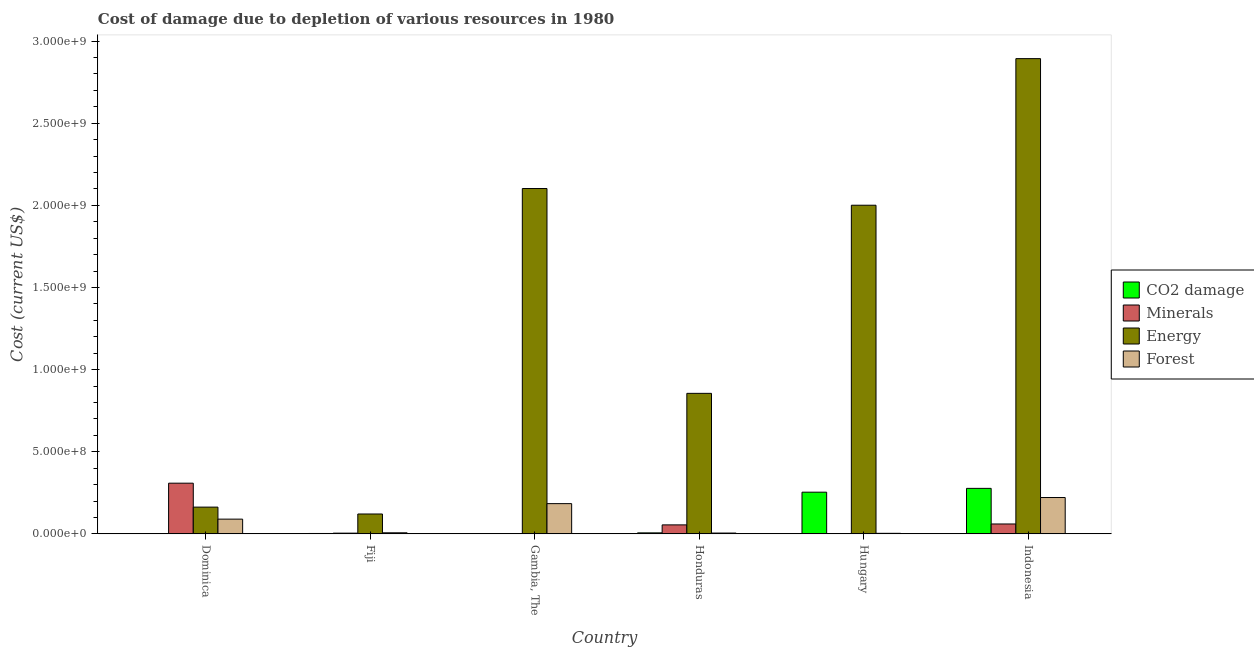How many bars are there on the 4th tick from the right?
Keep it short and to the point. 4. What is the label of the 2nd group of bars from the left?
Your answer should be compact. Fiji. What is the cost of damage due to depletion of coal in Honduras?
Provide a succinct answer. 6.01e+06. Across all countries, what is the maximum cost of damage due to depletion of minerals?
Give a very brief answer. 3.09e+08. Across all countries, what is the minimum cost of damage due to depletion of energy?
Provide a short and direct response. 1.21e+08. In which country was the cost of damage due to depletion of minerals maximum?
Provide a succinct answer. Dominica. In which country was the cost of damage due to depletion of energy minimum?
Provide a short and direct response. Fiji. What is the total cost of damage due to depletion of energy in the graph?
Provide a short and direct response. 8.14e+09. What is the difference between the cost of damage due to depletion of coal in Dominica and that in Honduras?
Your answer should be very brief. -5.90e+06. What is the difference between the cost of damage due to depletion of energy in Fiji and the cost of damage due to depletion of minerals in Indonesia?
Give a very brief answer. 6.08e+07. What is the average cost of damage due to depletion of forests per country?
Provide a short and direct response. 8.49e+07. What is the difference between the cost of damage due to depletion of energy and cost of damage due to depletion of minerals in Hungary?
Provide a short and direct response. 2.00e+09. In how many countries, is the cost of damage due to depletion of forests greater than 1900000000 US$?
Make the answer very short. 0. What is the ratio of the cost of damage due to depletion of coal in Fiji to that in Indonesia?
Ensure brevity in your answer.  0.01. Is the cost of damage due to depletion of energy in Dominica less than that in Fiji?
Make the answer very short. No. What is the difference between the highest and the second highest cost of damage due to depletion of minerals?
Make the answer very short. 2.48e+08. What is the difference between the highest and the lowest cost of damage due to depletion of minerals?
Give a very brief answer. 3.08e+08. What does the 1st bar from the left in Fiji represents?
Provide a short and direct response. CO2 damage. What does the 1st bar from the right in Honduras represents?
Offer a very short reply. Forest. Are all the bars in the graph horizontal?
Ensure brevity in your answer.  No. How many countries are there in the graph?
Your response must be concise. 6. Does the graph contain any zero values?
Provide a short and direct response. No. Does the graph contain grids?
Make the answer very short. No. Where does the legend appear in the graph?
Give a very brief answer. Center right. How many legend labels are there?
Make the answer very short. 4. What is the title of the graph?
Your answer should be compact. Cost of damage due to depletion of various resources in 1980 . What is the label or title of the X-axis?
Make the answer very short. Country. What is the label or title of the Y-axis?
Give a very brief answer. Cost (current US$). What is the Cost (current US$) in CO2 damage in Dominica?
Keep it short and to the point. 1.07e+05. What is the Cost (current US$) of Minerals in Dominica?
Your answer should be compact. 3.09e+08. What is the Cost (current US$) in Energy in Dominica?
Make the answer very short. 1.63e+08. What is the Cost (current US$) in Forest in Dominica?
Keep it short and to the point. 8.97e+07. What is the Cost (current US$) in CO2 damage in Fiji?
Your response must be concise. 2.33e+06. What is the Cost (current US$) in Minerals in Fiji?
Make the answer very short. 4.32e+06. What is the Cost (current US$) in Energy in Fiji?
Provide a short and direct response. 1.21e+08. What is the Cost (current US$) of Forest in Fiji?
Ensure brevity in your answer.  6.50e+06. What is the Cost (current US$) of CO2 damage in Gambia, The?
Offer a terse response. 4.61e+05. What is the Cost (current US$) in Minerals in Gambia, The?
Ensure brevity in your answer.  1.04e+06. What is the Cost (current US$) in Energy in Gambia, The?
Ensure brevity in your answer.  2.10e+09. What is the Cost (current US$) in Forest in Gambia, The?
Offer a terse response. 1.84e+08. What is the Cost (current US$) of CO2 damage in Honduras?
Keep it short and to the point. 6.01e+06. What is the Cost (current US$) in Minerals in Honduras?
Your response must be concise. 5.47e+07. What is the Cost (current US$) in Energy in Honduras?
Your answer should be compact. 8.56e+08. What is the Cost (current US$) of Forest in Honduras?
Offer a very short reply. 4.88e+06. What is the Cost (current US$) of CO2 damage in Hungary?
Make the answer very short. 2.54e+08. What is the Cost (current US$) in Minerals in Hungary?
Ensure brevity in your answer.  8.78e+04. What is the Cost (current US$) of Energy in Hungary?
Keep it short and to the point. 2.00e+09. What is the Cost (current US$) of Forest in Hungary?
Make the answer very short. 3.30e+06. What is the Cost (current US$) of CO2 damage in Indonesia?
Your answer should be very brief. 2.77e+08. What is the Cost (current US$) in Minerals in Indonesia?
Provide a succinct answer. 6.02e+07. What is the Cost (current US$) of Energy in Indonesia?
Give a very brief answer. 2.89e+09. What is the Cost (current US$) of Forest in Indonesia?
Your answer should be very brief. 2.21e+08. Across all countries, what is the maximum Cost (current US$) of CO2 damage?
Your answer should be very brief. 2.77e+08. Across all countries, what is the maximum Cost (current US$) of Minerals?
Your answer should be very brief. 3.09e+08. Across all countries, what is the maximum Cost (current US$) of Energy?
Your answer should be compact. 2.89e+09. Across all countries, what is the maximum Cost (current US$) in Forest?
Your response must be concise. 2.21e+08. Across all countries, what is the minimum Cost (current US$) in CO2 damage?
Offer a very short reply. 1.07e+05. Across all countries, what is the minimum Cost (current US$) in Minerals?
Make the answer very short. 8.78e+04. Across all countries, what is the minimum Cost (current US$) in Energy?
Offer a terse response. 1.21e+08. Across all countries, what is the minimum Cost (current US$) in Forest?
Offer a terse response. 3.30e+06. What is the total Cost (current US$) of CO2 damage in the graph?
Your answer should be compact. 5.40e+08. What is the total Cost (current US$) of Minerals in the graph?
Your answer should be very brief. 4.29e+08. What is the total Cost (current US$) in Energy in the graph?
Offer a very short reply. 8.14e+09. What is the total Cost (current US$) of Forest in the graph?
Your answer should be compact. 5.10e+08. What is the difference between the Cost (current US$) in CO2 damage in Dominica and that in Fiji?
Your response must be concise. -2.22e+06. What is the difference between the Cost (current US$) of Minerals in Dominica and that in Fiji?
Your response must be concise. 3.04e+08. What is the difference between the Cost (current US$) in Energy in Dominica and that in Fiji?
Provide a short and direct response. 4.19e+07. What is the difference between the Cost (current US$) of Forest in Dominica and that in Fiji?
Offer a very short reply. 8.32e+07. What is the difference between the Cost (current US$) in CO2 damage in Dominica and that in Gambia, The?
Your response must be concise. -3.54e+05. What is the difference between the Cost (current US$) of Minerals in Dominica and that in Gambia, The?
Your answer should be compact. 3.07e+08. What is the difference between the Cost (current US$) of Energy in Dominica and that in Gambia, The?
Your response must be concise. -1.94e+09. What is the difference between the Cost (current US$) of Forest in Dominica and that in Gambia, The?
Offer a terse response. -9.44e+07. What is the difference between the Cost (current US$) of CO2 damage in Dominica and that in Honduras?
Keep it short and to the point. -5.90e+06. What is the difference between the Cost (current US$) of Minerals in Dominica and that in Honduras?
Keep it short and to the point. 2.54e+08. What is the difference between the Cost (current US$) of Energy in Dominica and that in Honduras?
Give a very brief answer. -6.93e+08. What is the difference between the Cost (current US$) in Forest in Dominica and that in Honduras?
Keep it short and to the point. 8.48e+07. What is the difference between the Cost (current US$) of CO2 damage in Dominica and that in Hungary?
Your answer should be compact. -2.54e+08. What is the difference between the Cost (current US$) of Minerals in Dominica and that in Hungary?
Keep it short and to the point. 3.08e+08. What is the difference between the Cost (current US$) of Energy in Dominica and that in Hungary?
Offer a terse response. -1.84e+09. What is the difference between the Cost (current US$) in Forest in Dominica and that in Hungary?
Make the answer very short. 8.64e+07. What is the difference between the Cost (current US$) in CO2 damage in Dominica and that in Indonesia?
Offer a terse response. -2.77e+08. What is the difference between the Cost (current US$) in Minerals in Dominica and that in Indonesia?
Your answer should be very brief. 2.48e+08. What is the difference between the Cost (current US$) in Energy in Dominica and that in Indonesia?
Keep it short and to the point. -2.73e+09. What is the difference between the Cost (current US$) in Forest in Dominica and that in Indonesia?
Your answer should be compact. -1.32e+08. What is the difference between the Cost (current US$) in CO2 damage in Fiji and that in Gambia, The?
Give a very brief answer. 1.86e+06. What is the difference between the Cost (current US$) of Minerals in Fiji and that in Gambia, The?
Make the answer very short. 3.28e+06. What is the difference between the Cost (current US$) in Energy in Fiji and that in Gambia, The?
Offer a very short reply. -1.98e+09. What is the difference between the Cost (current US$) in Forest in Fiji and that in Gambia, The?
Your answer should be compact. -1.78e+08. What is the difference between the Cost (current US$) of CO2 damage in Fiji and that in Honduras?
Your answer should be compact. -3.69e+06. What is the difference between the Cost (current US$) of Minerals in Fiji and that in Honduras?
Offer a very short reply. -5.03e+07. What is the difference between the Cost (current US$) of Energy in Fiji and that in Honduras?
Your answer should be compact. -7.35e+08. What is the difference between the Cost (current US$) in Forest in Fiji and that in Honduras?
Make the answer very short. 1.61e+06. What is the difference between the Cost (current US$) of CO2 damage in Fiji and that in Hungary?
Your response must be concise. -2.51e+08. What is the difference between the Cost (current US$) of Minerals in Fiji and that in Hungary?
Provide a short and direct response. 4.23e+06. What is the difference between the Cost (current US$) in Energy in Fiji and that in Hungary?
Give a very brief answer. -1.88e+09. What is the difference between the Cost (current US$) in Forest in Fiji and that in Hungary?
Give a very brief answer. 3.20e+06. What is the difference between the Cost (current US$) of CO2 damage in Fiji and that in Indonesia?
Offer a very short reply. -2.75e+08. What is the difference between the Cost (current US$) in Minerals in Fiji and that in Indonesia?
Your answer should be compact. -5.59e+07. What is the difference between the Cost (current US$) in Energy in Fiji and that in Indonesia?
Your response must be concise. -2.77e+09. What is the difference between the Cost (current US$) of Forest in Fiji and that in Indonesia?
Your response must be concise. -2.15e+08. What is the difference between the Cost (current US$) in CO2 damage in Gambia, The and that in Honduras?
Provide a succinct answer. -5.55e+06. What is the difference between the Cost (current US$) of Minerals in Gambia, The and that in Honduras?
Offer a very short reply. -5.36e+07. What is the difference between the Cost (current US$) of Energy in Gambia, The and that in Honduras?
Offer a very short reply. 1.25e+09. What is the difference between the Cost (current US$) in Forest in Gambia, The and that in Honduras?
Offer a very short reply. 1.79e+08. What is the difference between the Cost (current US$) of CO2 damage in Gambia, The and that in Hungary?
Give a very brief answer. -2.53e+08. What is the difference between the Cost (current US$) in Minerals in Gambia, The and that in Hungary?
Your answer should be compact. 9.56e+05. What is the difference between the Cost (current US$) in Energy in Gambia, The and that in Hungary?
Offer a very short reply. 1.02e+08. What is the difference between the Cost (current US$) in Forest in Gambia, The and that in Hungary?
Ensure brevity in your answer.  1.81e+08. What is the difference between the Cost (current US$) of CO2 damage in Gambia, The and that in Indonesia?
Offer a terse response. -2.76e+08. What is the difference between the Cost (current US$) of Minerals in Gambia, The and that in Indonesia?
Your answer should be compact. -5.91e+07. What is the difference between the Cost (current US$) in Energy in Gambia, The and that in Indonesia?
Provide a short and direct response. -7.91e+08. What is the difference between the Cost (current US$) in Forest in Gambia, The and that in Indonesia?
Your answer should be very brief. -3.71e+07. What is the difference between the Cost (current US$) of CO2 damage in Honduras and that in Hungary?
Make the answer very short. -2.48e+08. What is the difference between the Cost (current US$) in Minerals in Honduras and that in Hungary?
Give a very brief answer. 5.46e+07. What is the difference between the Cost (current US$) of Energy in Honduras and that in Hungary?
Provide a succinct answer. -1.15e+09. What is the difference between the Cost (current US$) of Forest in Honduras and that in Hungary?
Make the answer very short. 1.59e+06. What is the difference between the Cost (current US$) of CO2 damage in Honduras and that in Indonesia?
Keep it short and to the point. -2.71e+08. What is the difference between the Cost (current US$) of Minerals in Honduras and that in Indonesia?
Ensure brevity in your answer.  -5.52e+06. What is the difference between the Cost (current US$) of Energy in Honduras and that in Indonesia?
Offer a very short reply. -2.04e+09. What is the difference between the Cost (current US$) of Forest in Honduras and that in Indonesia?
Ensure brevity in your answer.  -2.16e+08. What is the difference between the Cost (current US$) of CO2 damage in Hungary and that in Indonesia?
Ensure brevity in your answer.  -2.32e+07. What is the difference between the Cost (current US$) of Minerals in Hungary and that in Indonesia?
Offer a terse response. -6.01e+07. What is the difference between the Cost (current US$) in Energy in Hungary and that in Indonesia?
Offer a terse response. -8.92e+08. What is the difference between the Cost (current US$) of Forest in Hungary and that in Indonesia?
Provide a short and direct response. -2.18e+08. What is the difference between the Cost (current US$) of CO2 damage in Dominica and the Cost (current US$) of Minerals in Fiji?
Ensure brevity in your answer.  -4.21e+06. What is the difference between the Cost (current US$) of CO2 damage in Dominica and the Cost (current US$) of Energy in Fiji?
Ensure brevity in your answer.  -1.21e+08. What is the difference between the Cost (current US$) in CO2 damage in Dominica and the Cost (current US$) in Forest in Fiji?
Keep it short and to the point. -6.39e+06. What is the difference between the Cost (current US$) in Minerals in Dominica and the Cost (current US$) in Energy in Fiji?
Give a very brief answer. 1.88e+08. What is the difference between the Cost (current US$) in Minerals in Dominica and the Cost (current US$) in Forest in Fiji?
Keep it short and to the point. 3.02e+08. What is the difference between the Cost (current US$) of Energy in Dominica and the Cost (current US$) of Forest in Fiji?
Provide a succinct answer. 1.56e+08. What is the difference between the Cost (current US$) of CO2 damage in Dominica and the Cost (current US$) of Minerals in Gambia, The?
Ensure brevity in your answer.  -9.37e+05. What is the difference between the Cost (current US$) of CO2 damage in Dominica and the Cost (current US$) of Energy in Gambia, The?
Offer a terse response. -2.10e+09. What is the difference between the Cost (current US$) of CO2 damage in Dominica and the Cost (current US$) of Forest in Gambia, The?
Your answer should be compact. -1.84e+08. What is the difference between the Cost (current US$) of Minerals in Dominica and the Cost (current US$) of Energy in Gambia, The?
Your response must be concise. -1.79e+09. What is the difference between the Cost (current US$) in Minerals in Dominica and the Cost (current US$) in Forest in Gambia, The?
Make the answer very short. 1.24e+08. What is the difference between the Cost (current US$) in Energy in Dominica and the Cost (current US$) in Forest in Gambia, The?
Provide a succinct answer. -2.12e+07. What is the difference between the Cost (current US$) of CO2 damage in Dominica and the Cost (current US$) of Minerals in Honduras?
Ensure brevity in your answer.  -5.46e+07. What is the difference between the Cost (current US$) in CO2 damage in Dominica and the Cost (current US$) in Energy in Honduras?
Provide a succinct answer. -8.55e+08. What is the difference between the Cost (current US$) in CO2 damage in Dominica and the Cost (current US$) in Forest in Honduras?
Your answer should be compact. -4.78e+06. What is the difference between the Cost (current US$) in Minerals in Dominica and the Cost (current US$) in Energy in Honduras?
Give a very brief answer. -5.47e+08. What is the difference between the Cost (current US$) of Minerals in Dominica and the Cost (current US$) of Forest in Honduras?
Offer a terse response. 3.04e+08. What is the difference between the Cost (current US$) of Energy in Dominica and the Cost (current US$) of Forest in Honduras?
Offer a terse response. 1.58e+08. What is the difference between the Cost (current US$) of CO2 damage in Dominica and the Cost (current US$) of Minerals in Hungary?
Provide a succinct answer. 1.94e+04. What is the difference between the Cost (current US$) of CO2 damage in Dominica and the Cost (current US$) of Energy in Hungary?
Keep it short and to the point. -2.00e+09. What is the difference between the Cost (current US$) in CO2 damage in Dominica and the Cost (current US$) in Forest in Hungary?
Your answer should be very brief. -3.19e+06. What is the difference between the Cost (current US$) in Minerals in Dominica and the Cost (current US$) in Energy in Hungary?
Your response must be concise. -1.69e+09. What is the difference between the Cost (current US$) of Minerals in Dominica and the Cost (current US$) of Forest in Hungary?
Give a very brief answer. 3.05e+08. What is the difference between the Cost (current US$) of Energy in Dominica and the Cost (current US$) of Forest in Hungary?
Offer a terse response. 1.60e+08. What is the difference between the Cost (current US$) of CO2 damage in Dominica and the Cost (current US$) of Minerals in Indonesia?
Keep it short and to the point. -6.01e+07. What is the difference between the Cost (current US$) in CO2 damage in Dominica and the Cost (current US$) in Energy in Indonesia?
Provide a short and direct response. -2.89e+09. What is the difference between the Cost (current US$) of CO2 damage in Dominica and the Cost (current US$) of Forest in Indonesia?
Your response must be concise. -2.21e+08. What is the difference between the Cost (current US$) in Minerals in Dominica and the Cost (current US$) in Energy in Indonesia?
Ensure brevity in your answer.  -2.58e+09. What is the difference between the Cost (current US$) of Minerals in Dominica and the Cost (current US$) of Forest in Indonesia?
Keep it short and to the point. 8.73e+07. What is the difference between the Cost (current US$) in Energy in Dominica and the Cost (current US$) in Forest in Indonesia?
Offer a very short reply. -5.84e+07. What is the difference between the Cost (current US$) of CO2 damage in Fiji and the Cost (current US$) of Minerals in Gambia, The?
Provide a short and direct response. 1.28e+06. What is the difference between the Cost (current US$) of CO2 damage in Fiji and the Cost (current US$) of Energy in Gambia, The?
Offer a terse response. -2.10e+09. What is the difference between the Cost (current US$) of CO2 damage in Fiji and the Cost (current US$) of Forest in Gambia, The?
Your answer should be compact. -1.82e+08. What is the difference between the Cost (current US$) in Minerals in Fiji and the Cost (current US$) in Energy in Gambia, The?
Give a very brief answer. -2.10e+09. What is the difference between the Cost (current US$) in Minerals in Fiji and the Cost (current US$) in Forest in Gambia, The?
Provide a succinct answer. -1.80e+08. What is the difference between the Cost (current US$) in Energy in Fiji and the Cost (current US$) in Forest in Gambia, The?
Provide a succinct answer. -6.31e+07. What is the difference between the Cost (current US$) of CO2 damage in Fiji and the Cost (current US$) of Minerals in Honduras?
Your answer should be very brief. -5.23e+07. What is the difference between the Cost (current US$) in CO2 damage in Fiji and the Cost (current US$) in Energy in Honduras?
Your answer should be compact. -8.53e+08. What is the difference between the Cost (current US$) of CO2 damage in Fiji and the Cost (current US$) of Forest in Honduras?
Keep it short and to the point. -2.56e+06. What is the difference between the Cost (current US$) in Minerals in Fiji and the Cost (current US$) in Energy in Honduras?
Your response must be concise. -8.51e+08. What is the difference between the Cost (current US$) of Minerals in Fiji and the Cost (current US$) of Forest in Honduras?
Your answer should be compact. -5.63e+05. What is the difference between the Cost (current US$) of Energy in Fiji and the Cost (current US$) of Forest in Honduras?
Your answer should be very brief. 1.16e+08. What is the difference between the Cost (current US$) in CO2 damage in Fiji and the Cost (current US$) in Minerals in Hungary?
Provide a short and direct response. 2.24e+06. What is the difference between the Cost (current US$) of CO2 damage in Fiji and the Cost (current US$) of Energy in Hungary?
Your response must be concise. -2.00e+09. What is the difference between the Cost (current US$) in CO2 damage in Fiji and the Cost (current US$) in Forest in Hungary?
Ensure brevity in your answer.  -9.72e+05. What is the difference between the Cost (current US$) in Minerals in Fiji and the Cost (current US$) in Energy in Hungary?
Provide a short and direct response. -2.00e+09. What is the difference between the Cost (current US$) of Minerals in Fiji and the Cost (current US$) of Forest in Hungary?
Provide a succinct answer. 1.02e+06. What is the difference between the Cost (current US$) in Energy in Fiji and the Cost (current US$) in Forest in Hungary?
Keep it short and to the point. 1.18e+08. What is the difference between the Cost (current US$) in CO2 damage in Fiji and the Cost (current US$) in Minerals in Indonesia?
Offer a very short reply. -5.78e+07. What is the difference between the Cost (current US$) in CO2 damage in Fiji and the Cost (current US$) in Energy in Indonesia?
Make the answer very short. -2.89e+09. What is the difference between the Cost (current US$) in CO2 damage in Fiji and the Cost (current US$) in Forest in Indonesia?
Give a very brief answer. -2.19e+08. What is the difference between the Cost (current US$) of Minerals in Fiji and the Cost (current US$) of Energy in Indonesia?
Keep it short and to the point. -2.89e+09. What is the difference between the Cost (current US$) of Minerals in Fiji and the Cost (current US$) of Forest in Indonesia?
Give a very brief answer. -2.17e+08. What is the difference between the Cost (current US$) in Energy in Fiji and the Cost (current US$) in Forest in Indonesia?
Offer a very short reply. -1.00e+08. What is the difference between the Cost (current US$) of CO2 damage in Gambia, The and the Cost (current US$) of Minerals in Honduras?
Ensure brevity in your answer.  -5.42e+07. What is the difference between the Cost (current US$) of CO2 damage in Gambia, The and the Cost (current US$) of Energy in Honduras?
Ensure brevity in your answer.  -8.55e+08. What is the difference between the Cost (current US$) in CO2 damage in Gambia, The and the Cost (current US$) in Forest in Honduras?
Keep it short and to the point. -4.42e+06. What is the difference between the Cost (current US$) in Minerals in Gambia, The and the Cost (current US$) in Energy in Honduras?
Your answer should be compact. -8.54e+08. What is the difference between the Cost (current US$) in Minerals in Gambia, The and the Cost (current US$) in Forest in Honduras?
Keep it short and to the point. -3.84e+06. What is the difference between the Cost (current US$) of Energy in Gambia, The and the Cost (current US$) of Forest in Honduras?
Your response must be concise. 2.10e+09. What is the difference between the Cost (current US$) in CO2 damage in Gambia, The and the Cost (current US$) in Minerals in Hungary?
Make the answer very short. 3.73e+05. What is the difference between the Cost (current US$) in CO2 damage in Gambia, The and the Cost (current US$) in Energy in Hungary?
Keep it short and to the point. -2.00e+09. What is the difference between the Cost (current US$) in CO2 damage in Gambia, The and the Cost (current US$) in Forest in Hungary?
Your response must be concise. -2.84e+06. What is the difference between the Cost (current US$) in Minerals in Gambia, The and the Cost (current US$) in Energy in Hungary?
Your answer should be very brief. -2.00e+09. What is the difference between the Cost (current US$) in Minerals in Gambia, The and the Cost (current US$) in Forest in Hungary?
Provide a short and direct response. -2.25e+06. What is the difference between the Cost (current US$) of Energy in Gambia, The and the Cost (current US$) of Forest in Hungary?
Provide a short and direct response. 2.10e+09. What is the difference between the Cost (current US$) in CO2 damage in Gambia, The and the Cost (current US$) in Minerals in Indonesia?
Make the answer very short. -5.97e+07. What is the difference between the Cost (current US$) in CO2 damage in Gambia, The and the Cost (current US$) in Energy in Indonesia?
Your answer should be very brief. -2.89e+09. What is the difference between the Cost (current US$) of CO2 damage in Gambia, The and the Cost (current US$) of Forest in Indonesia?
Your answer should be very brief. -2.21e+08. What is the difference between the Cost (current US$) of Minerals in Gambia, The and the Cost (current US$) of Energy in Indonesia?
Provide a short and direct response. -2.89e+09. What is the difference between the Cost (current US$) in Minerals in Gambia, The and the Cost (current US$) in Forest in Indonesia?
Offer a terse response. -2.20e+08. What is the difference between the Cost (current US$) of Energy in Gambia, The and the Cost (current US$) of Forest in Indonesia?
Keep it short and to the point. 1.88e+09. What is the difference between the Cost (current US$) of CO2 damage in Honduras and the Cost (current US$) of Minerals in Hungary?
Provide a succinct answer. 5.92e+06. What is the difference between the Cost (current US$) of CO2 damage in Honduras and the Cost (current US$) of Energy in Hungary?
Make the answer very short. -1.99e+09. What is the difference between the Cost (current US$) of CO2 damage in Honduras and the Cost (current US$) of Forest in Hungary?
Your answer should be very brief. 2.71e+06. What is the difference between the Cost (current US$) of Minerals in Honduras and the Cost (current US$) of Energy in Hungary?
Ensure brevity in your answer.  -1.95e+09. What is the difference between the Cost (current US$) in Minerals in Honduras and the Cost (current US$) in Forest in Hungary?
Give a very brief answer. 5.14e+07. What is the difference between the Cost (current US$) of Energy in Honduras and the Cost (current US$) of Forest in Hungary?
Ensure brevity in your answer.  8.52e+08. What is the difference between the Cost (current US$) in CO2 damage in Honduras and the Cost (current US$) in Minerals in Indonesia?
Your answer should be compact. -5.42e+07. What is the difference between the Cost (current US$) in CO2 damage in Honduras and the Cost (current US$) in Energy in Indonesia?
Ensure brevity in your answer.  -2.89e+09. What is the difference between the Cost (current US$) of CO2 damage in Honduras and the Cost (current US$) of Forest in Indonesia?
Keep it short and to the point. -2.15e+08. What is the difference between the Cost (current US$) in Minerals in Honduras and the Cost (current US$) in Energy in Indonesia?
Provide a short and direct response. -2.84e+09. What is the difference between the Cost (current US$) of Minerals in Honduras and the Cost (current US$) of Forest in Indonesia?
Keep it short and to the point. -1.67e+08. What is the difference between the Cost (current US$) of Energy in Honduras and the Cost (current US$) of Forest in Indonesia?
Offer a terse response. 6.34e+08. What is the difference between the Cost (current US$) of CO2 damage in Hungary and the Cost (current US$) of Minerals in Indonesia?
Offer a terse response. 1.94e+08. What is the difference between the Cost (current US$) of CO2 damage in Hungary and the Cost (current US$) of Energy in Indonesia?
Your answer should be very brief. -2.64e+09. What is the difference between the Cost (current US$) in CO2 damage in Hungary and the Cost (current US$) in Forest in Indonesia?
Your answer should be compact. 3.26e+07. What is the difference between the Cost (current US$) of Minerals in Hungary and the Cost (current US$) of Energy in Indonesia?
Offer a terse response. -2.89e+09. What is the difference between the Cost (current US$) in Minerals in Hungary and the Cost (current US$) in Forest in Indonesia?
Give a very brief answer. -2.21e+08. What is the difference between the Cost (current US$) of Energy in Hungary and the Cost (current US$) of Forest in Indonesia?
Make the answer very short. 1.78e+09. What is the average Cost (current US$) in CO2 damage per country?
Your response must be concise. 8.99e+07. What is the average Cost (current US$) of Minerals per country?
Make the answer very short. 7.15e+07. What is the average Cost (current US$) in Energy per country?
Your response must be concise. 1.36e+09. What is the average Cost (current US$) of Forest per country?
Offer a very short reply. 8.49e+07. What is the difference between the Cost (current US$) of CO2 damage and Cost (current US$) of Minerals in Dominica?
Provide a short and direct response. -3.08e+08. What is the difference between the Cost (current US$) of CO2 damage and Cost (current US$) of Energy in Dominica?
Your answer should be very brief. -1.63e+08. What is the difference between the Cost (current US$) in CO2 damage and Cost (current US$) in Forest in Dominica?
Provide a short and direct response. -8.96e+07. What is the difference between the Cost (current US$) in Minerals and Cost (current US$) in Energy in Dominica?
Give a very brief answer. 1.46e+08. What is the difference between the Cost (current US$) of Minerals and Cost (current US$) of Forest in Dominica?
Make the answer very short. 2.19e+08. What is the difference between the Cost (current US$) in Energy and Cost (current US$) in Forest in Dominica?
Your response must be concise. 7.32e+07. What is the difference between the Cost (current US$) of CO2 damage and Cost (current US$) of Minerals in Fiji?
Your answer should be very brief. -2.00e+06. What is the difference between the Cost (current US$) of CO2 damage and Cost (current US$) of Energy in Fiji?
Your response must be concise. -1.19e+08. What is the difference between the Cost (current US$) of CO2 damage and Cost (current US$) of Forest in Fiji?
Offer a very short reply. -4.17e+06. What is the difference between the Cost (current US$) in Minerals and Cost (current US$) in Energy in Fiji?
Make the answer very short. -1.17e+08. What is the difference between the Cost (current US$) in Minerals and Cost (current US$) in Forest in Fiji?
Offer a terse response. -2.18e+06. What is the difference between the Cost (current US$) in Energy and Cost (current US$) in Forest in Fiji?
Provide a succinct answer. 1.14e+08. What is the difference between the Cost (current US$) of CO2 damage and Cost (current US$) of Minerals in Gambia, The?
Give a very brief answer. -5.83e+05. What is the difference between the Cost (current US$) of CO2 damage and Cost (current US$) of Energy in Gambia, The?
Offer a very short reply. -2.10e+09. What is the difference between the Cost (current US$) of CO2 damage and Cost (current US$) of Forest in Gambia, The?
Give a very brief answer. -1.84e+08. What is the difference between the Cost (current US$) of Minerals and Cost (current US$) of Energy in Gambia, The?
Provide a short and direct response. -2.10e+09. What is the difference between the Cost (current US$) of Minerals and Cost (current US$) of Forest in Gambia, The?
Keep it short and to the point. -1.83e+08. What is the difference between the Cost (current US$) of Energy and Cost (current US$) of Forest in Gambia, The?
Your answer should be compact. 1.92e+09. What is the difference between the Cost (current US$) of CO2 damage and Cost (current US$) of Minerals in Honduras?
Ensure brevity in your answer.  -4.86e+07. What is the difference between the Cost (current US$) of CO2 damage and Cost (current US$) of Energy in Honduras?
Offer a terse response. -8.50e+08. What is the difference between the Cost (current US$) of CO2 damage and Cost (current US$) of Forest in Honduras?
Your response must be concise. 1.13e+06. What is the difference between the Cost (current US$) of Minerals and Cost (current US$) of Energy in Honduras?
Your answer should be compact. -8.01e+08. What is the difference between the Cost (current US$) in Minerals and Cost (current US$) in Forest in Honduras?
Your response must be concise. 4.98e+07. What is the difference between the Cost (current US$) of Energy and Cost (current US$) of Forest in Honduras?
Offer a terse response. 8.51e+08. What is the difference between the Cost (current US$) in CO2 damage and Cost (current US$) in Minerals in Hungary?
Give a very brief answer. 2.54e+08. What is the difference between the Cost (current US$) in CO2 damage and Cost (current US$) in Energy in Hungary?
Provide a succinct answer. -1.75e+09. What is the difference between the Cost (current US$) of CO2 damage and Cost (current US$) of Forest in Hungary?
Your answer should be compact. 2.51e+08. What is the difference between the Cost (current US$) of Minerals and Cost (current US$) of Energy in Hungary?
Provide a short and direct response. -2.00e+09. What is the difference between the Cost (current US$) of Minerals and Cost (current US$) of Forest in Hungary?
Offer a very short reply. -3.21e+06. What is the difference between the Cost (current US$) of Energy and Cost (current US$) of Forest in Hungary?
Provide a short and direct response. 2.00e+09. What is the difference between the Cost (current US$) in CO2 damage and Cost (current US$) in Minerals in Indonesia?
Offer a very short reply. 2.17e+08. What is the difference between the Cost (current US$) in CO2 damage and Cost (current US$) in Energy in Indonesia?
Provide a succinct answer. -2.62e+09. What is the difference between the Cost (current US$) of CO2 damage and Cost (current US$) of Forest in Indonesia?
Ensure brevity in your answer.  5.57e+07. What is the difference between the Cost (current US$) of Minerals and Cost (current US$) of Energy in Indonesia?
Keep it short and to the point. -2.83e+09. What is the difference between the Cost (current US$) in Minerals and Cost (current US$) in Forest in Indonesia?
Keep it short and to the point. -1.61e+08. What is the difference between the Cost (current US$) of Energy and Cost (current US$) of Forest in Indonesia?
Provide a succinct answer. 2.67e+09. What is the ratio of the Cost (current US$) of CO2 damage in Dominica to that in Fiji?
Provide a short and direct response. 0.05. What is the ratio of the Cost (current US$) of Minerals in Dominica to that in Fiji?
Offer a very short reply. 71.4. What is the ratio of the Cost (current US$) of Energy in Dominica to that in Fiji?
Keep it short and to the point. 1.35. What is the ratio of the Cost (current US$) of Forest in Dominica to that in Fiji?
Offer a terse response. 13.8. What is the ratio of the Cost (current US$) of CO2 damage in Dominica to that in Gambia, The?
Offer a terse response. 0.23. What is the ratio of the Cost (current US$) of Minerals in Dominica to that in Gambia, The?
Your response must be concise. 295.57. What is the ratio of the Cost (current US$) in Energy in Dominica to that in Gambia, The?
Ensure brevity in your answer.  0.08. What is the ratio of the Cost (current US$) in Forest in Dominica to that in Gambia, The?
Make the answer very short. 0.49. What is the ratio of the Cost (current US$) in CO2 damage in Dominica to that in Honduras?
Provide a succinct answer. 0.02. What is the ratio of the Cost (current US$) of Minerals in Dominica to that in Honduras?
Ensure brevity in your answer.  5.64. What is the ratio of the Cost (current US$) in Energy in Dominica to that in Honduras?
Provide a short and direct response. 0.19. What is the ratio of the Cost (current US$) in Forest in Dominica to that in Honduras?
Offer a terse response. 18.36. What is the ratio of the Cost (current US$) in CO2 damage in Dominica to that in Hungary?
Give a very brief answer. 0. What is the ratio of the Cost (current US$) in Minerals in Dominica to that in Hungary?
Give a very brief answer. 3515.24. What is the ratio of the Cost (current US$) in Energy in Dominica to that in Hungary?
Give a very brief answer. 0.08. What is the ratio of the Cost (current US$) in Forest in Dominica to that in Hungary?
Offer a terse response. 27.2. What is the ratio of the Cost (current US$) of Minerals in Dominica to that in Indonesia?
Provide a succinct answer. 5.13. What is the ratio of the Cost (current US$) of Energy in Dominica to that in Indonesia?
Keep it short and to the point. 0.06. What is the ratio of the Cost (current US$) of Forest in Dominica to that in Indonesia?
Provide a short and direct response. 0.41. What is the ratio of the Cost (current US$) of CO2 damage in Fiji to that in Gambia, The?
Ensure brevity in your answer.  5.05. What is the ratio of the Cost (current US$) of Minerals in Fiji to that in Gambia, The?
Give a very brief answer. 4.14. What is the ratio of the Cost (current US$) in Energy in Fiji to that in Gambia, The?
Offer a terse response. 0.06. What is the ratio of the Cost (current US$) of Forest in Fiji to that in Gambia, The?
Give a very brief answer. 0.04. What is the ratio of the Cost (current US$) in CO2 damage in Fiji to that in Honduras?
Make the answer very short. 0.39. What is the ratio of the Cost (current US$) of Minerals in Fiji to that in Honduras?
Your answer should be very brief. 0.08. What is the ratio of the Cost (current US$) of Energy in Fiji to that in Honduras?
Give a very brief answer. 0.14. What is the ratio of the Cost (current US$) of Forest in Fiji to that in Honduras?
Offer a very short reply. 1.33. What is the ratio of the Cost (current US$) in CO2 damage in Fiji to that in Hungary?
Provide a short and direct response. 0.01. What is the ratio of the Cost (current US$) in Minerals in Fiji to that in Hungary?
Your response must be concise. 49.23. What is the ratio of the Cost (current US$) of Energy in Fiji to that in Hungary?
Offer a terse response. 0.06. What is the ratio of the Cost (current US$) of Forest in Fiji to that in Hungary?
Your answer should be compact. 1.97. What is the ratio of the Cost (current US$) of CO2 damage in Fiji to that in Indonesia?
Provide a short and direct response. 0.01. What is the ratio of the Cost (current US$) of Minerals in Fiji to that in Indonesia?
Make the answer very short. 0.07. What is the ratio of the Cost (current US$) in Energy in Fiji to that in Indonesia?
Provide a short and direct response. 0.04. What is the ratio of the Cost (current US$) in Forest in Fiji to that in Indonesia?
Your response must be concise. 0.03. What is the ratio of the Cost (current US$) in CO2 damage in Gambia, The to that in Honduras?
Give a very brief answer. 0.08. What is the ratio of the Cost (current US$) of Minerals in Gambia, The to that in Honduras?
Your response must be concise. 0.02. What is the ratio of the Cost (current US$) in Energy in Gambia, The to that in Honduras?
Provide a short and direct response. 2.46. What is the ratio of the Cost (current US$) of Forest in Gambia, The to that in Honduras?
Make the answer very short. 37.69. What is the ratio of the Cost (current US$) of CO2 damage in Gambia, The to that in Hungary?
Your response must be concise. 0. What is the ratio of the Cost (current US$) of Minerals in Gambia, The to that in Hungary?
Provide a short and direct response. 11.89. What is the ratio of the Cost (current US$) in Energy in Gambia, The to that in Hungary?
Your answer should be compact. 1.05. What is the ratio of the Cost (current US$) of Forest in Gambia, The to that in Hungary?
Offer a very short reply. 55.83. What is the ratio of the Cost (current US$) in CO2 damage in Gambia, The to that in Indonesia?
Make the answer very short. 0. What is the ratio of the Cost (current US$) in Minerals in Gambia, The to that in Indonesia?
Provide a succinct answer. 0.02. What is the ratio of the Cost (current US$) of Energy in Gambia, The to that in Indonesia?
Your answer should be compact. 0.73. What is the ratio of the Cost (current US$) in Forest in Gambia, The to that in Indonesia?
Provide a succinct answer. 0.83. What is the ratio of the Cost (current US$) of CO2 damage in Honduras to that in Hungary?
Give a very brief answer. 0.02. What is the ratio of the Cost (current US$) of Minerals in Honduras to that in Hungary?
Your answer should be compact. 622.73. What is the ratio of the Cost (current US$) of Energy in Honduras to that in Hungary?
Provide a short and direct response. 0.43. What is the ratio of the Cost (current US$) of Forest in Honduras to that in Hungary?
Make the answer very short. 1.48. What is the ratio of the Cost (current US$) in CO2 damage in Honduras to that in Indonesia?
Make the answer very short. 0.02. What is the ratio of the Cost (current US$) of Minerals in Honduras to that in Indonesia?
Keep it short and to the point. 0.91. What is the ratio of the Cost (current US$) in Energy in Honduras to that in Indonesia?
Provide a short and direct response. 0.3. What is the ratio of the Cost (current US$) in Forest in Honduras to that in Indonesia?
Keep it short and to the point. 0.02. What is the ratio of the Cost (current US$) in CO2 damage in Hungary to that in Indonesia?
Your response must be concise. 0.92. What is the ratio of the Cost (current US$) of Minerals in Hungary to that in Indonesia?
Keep it short and to the point. 0. What is the ratio of the Cost (current US$) in Energy in Hungary to that in Indonesia?
Provide a short and direct response. 0.69. What is the ratio of the Cost (current US$) in Forest in Hungary to that in Indonesia?
Make the answer very short. 0.01. What is the difference between the highest and the second highest Cost (current US$) of CO2 damage?
Ensure brevity in your answer.  2.32e+07. What is the difference between the highest and the second highest Cost (current US$) of Minerals?
Offer a terse response. 2.48e+08. What is the difference between the highest and the second highest Cost (current US$) in Energy?
Provide a succinct answer. 7.91e+08. What is the difference between the highest and the second highest Cost (current US$) in Forest?
Give a very brief answer. 3.71e+07. What is the difference between the highest and the lowest Cost (current US$) in CO2 damage?
Provide a succinct answer. 2.77e+08. What is the difference between the highest and the lowest Cost (current US$) in Minerals?
Offer a very short reply. 3.08e+08. What is the difference between the highest and the lowest Cost (current US$) in Energy?
Your response must be concise. 2.77e+09. What is the difference between the highest and the lowest Cost (current US$) in Forest?
Your answer should be very brief. 2.18e+08. 